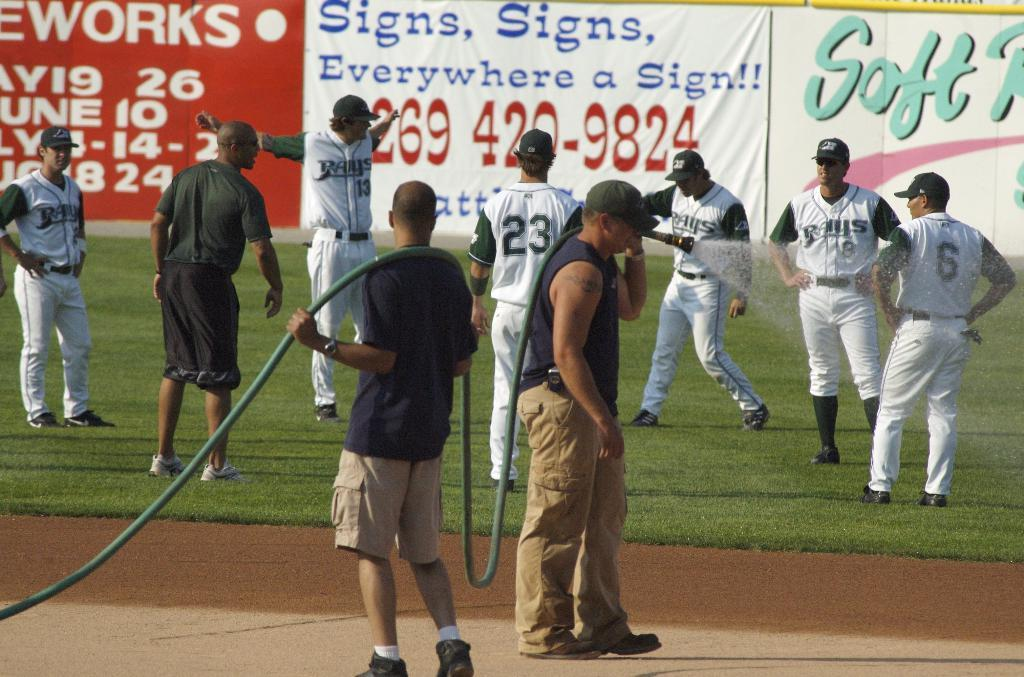Provide a one-sentence caption for the provided image. Numerous baseball players of the Rays on the outfield grass of a baseball field. 